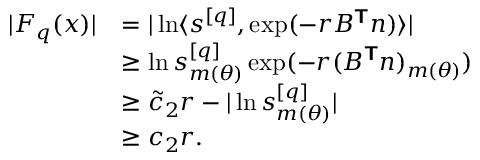Convert formula to latex. <formula><loc_0><loc_0><loc_500><loc_500>\begin{array} { r l } { | F _ { q } ( x ) | } & { = | \ln \langle s ^ { [ q ] } , \exp ( - r B ^ { T } n ) \rangle | } \\ & { \geq \ln s _ { m ( { \theta } ) } ^ { [ q ] } \exp ( - r ( B ^ { T } n ) _ { m ( { \theta } ) } ) } \\ & { \geq \tilde { c } _ { 2 } r - | \ln s _ { m ( { \theta } ) } ^ { [ q ] } | } \\ & { \geq c _ { 2 } r . } \end{array}</formula> 